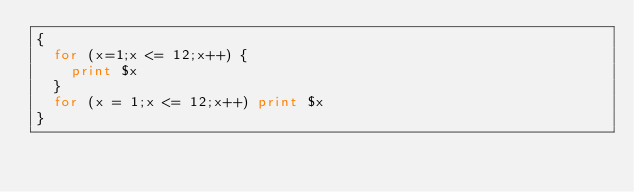Convert code to text. <code><loc_0><loc_0><loc_500><loc_500><_Awk_>{
  for (x=1;x <= 12;x++) {
    print $x
  }
  for (x = 1;x <= 12;x++) print $x
}
</code> 